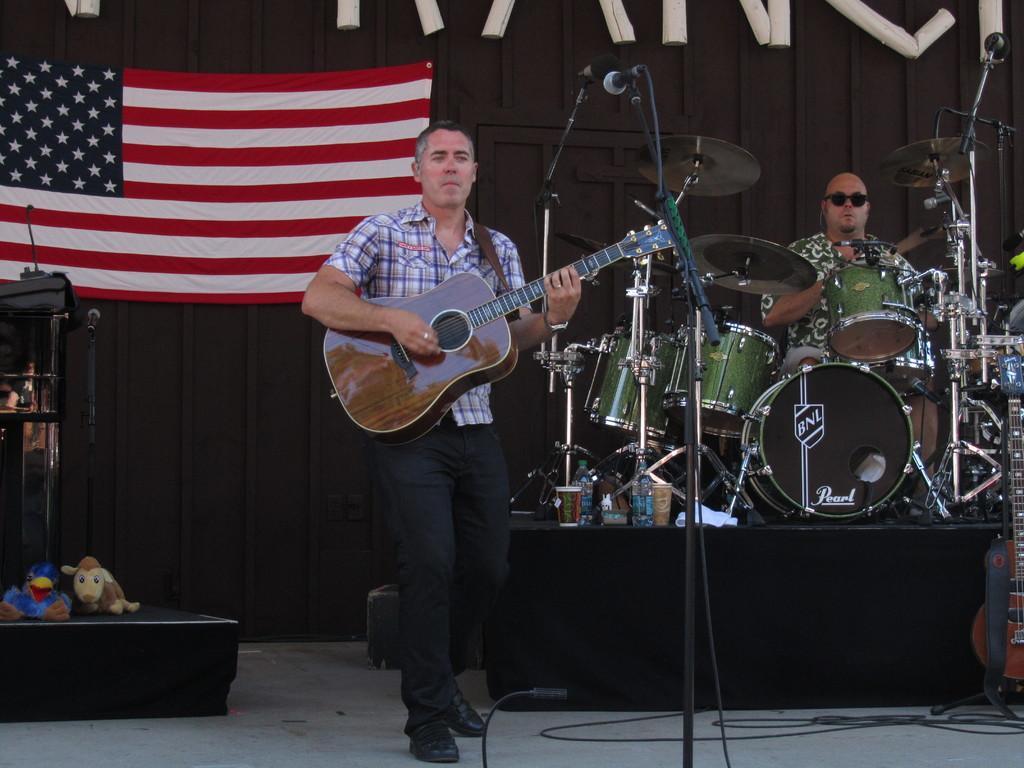Describe this image in one or two sentences. In this image i can see a person wearing shirt and pant standing and holding a guitar, I can see microphone in front of him. In the background i can see a flag,a wall ,a person sitting in front of musical instruments and few wires. 